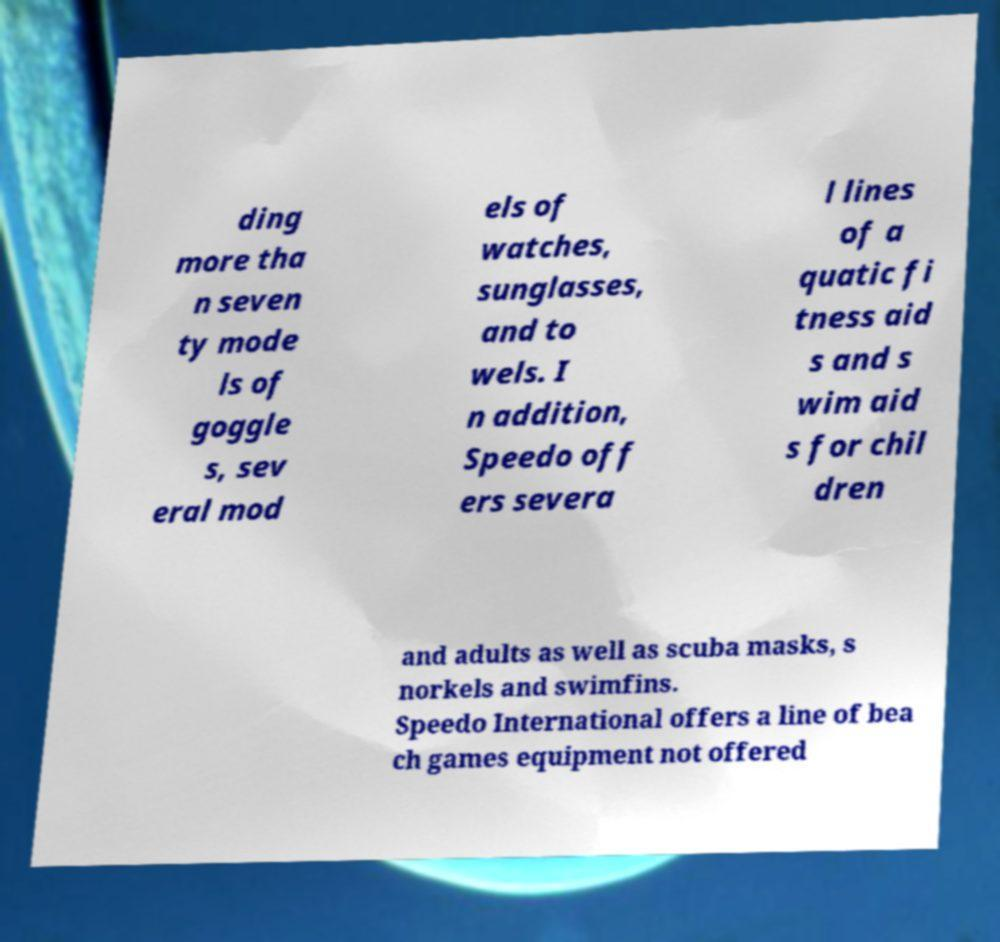There's text embedded in this image that I need extracted. Can you transcribe it verbatim? ding more tha n seven ty mode ls of goggle s, sev eral mod els of watches, sunglasses, and to wels. I n addition, Speedo off ers severa l lines of a quatic fi tness aid s and s wim aid s for chil dren and adults as well as scuba masks, s norkels and swimfins. Speedo International offers a line of bea ch games equipment not offered 